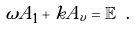<formula> <loc_0><loc_0><loc_500><loc_500>\omega A _ { 1 } + k A _ { v } = \mathbb { E } \ .</formula> 